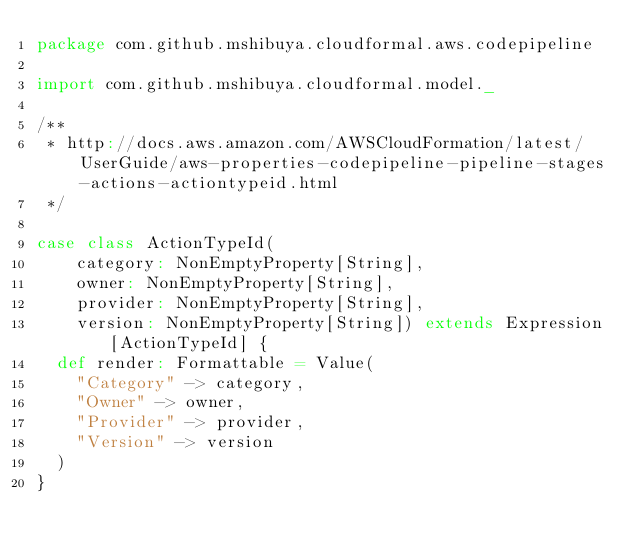<code> <loc_0><loc_0><loc_500><loc_500><_Scala_>package com.github.mshibuya.cloudformal.aws.codepipeline

import com.github.mshibuya.cloudformal.model._

/**
 * http://docs.aws.amazon.com/AWSCloudFormation/latest/UserGuide/aws-properties-codepipeline-pipeline-stages-actions-actiontypeid.html
 */

case class ActionTypeId(
    category: NonEmptyProperty[String],
    owner: NonEmptyProperty[String],
    provider: NonEmptyProperty[String],
    version: NonEmptyProperty[String]) extends Expression[ActionTypeId] {
  def render: Formattable = Value(
    "Category" -> category,
    "Owner" -> owner,
    "Provider" -> provider,
    "Version" -> version
  )
}
</code> 